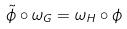<formula> <loc_0><loc_0><loc_500><loc_500>\tilde { \phi } \circ \omega _ { G } = \omega _ { H } \circ \phi</formula> 